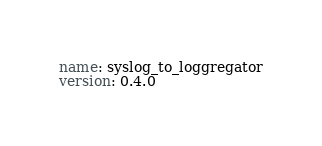Convert code to text. <code><loc_0><loc_0><loc_500><loc_500><_YAML_>name: syslog_to_loggregator
version: 0.4.0</code> 